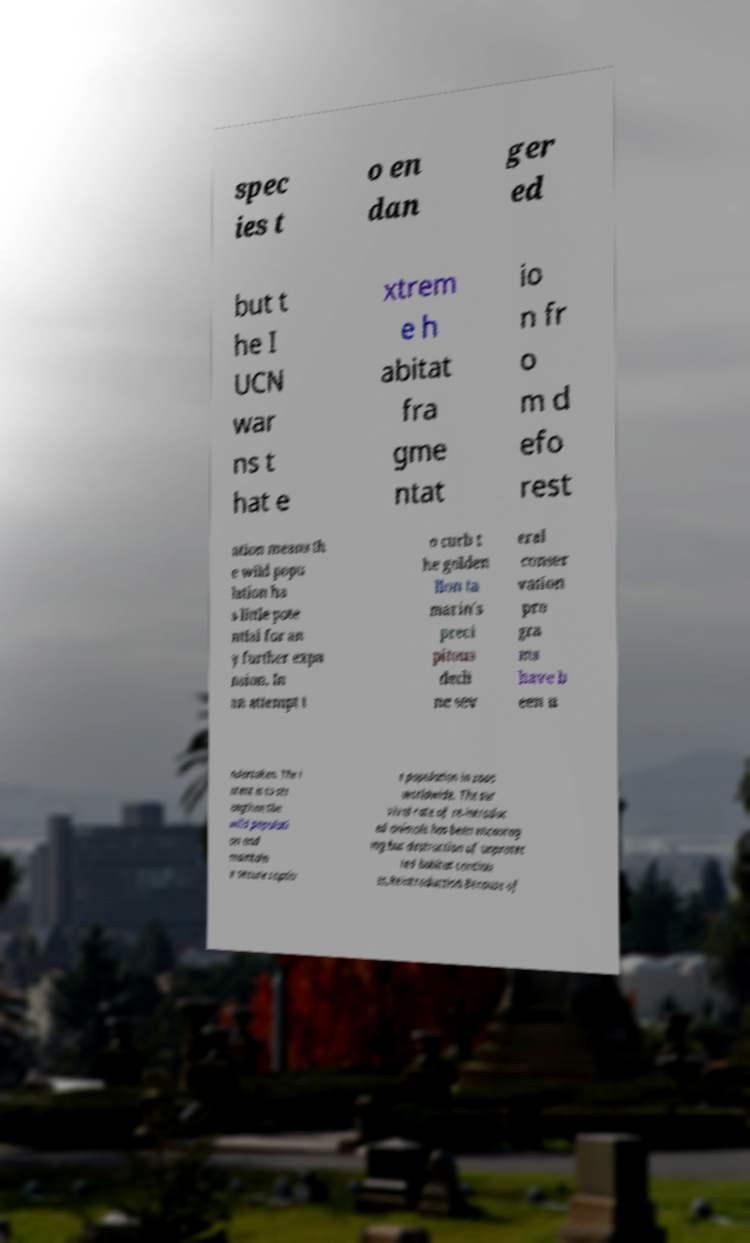Please read and relay the text visible in this image. What does it say? spec ies t o en dan ger ed but t he I UCN war ns t hat e xtrem e h abitat fra gme ntat io n fr o m d efo rest ation means th e wild popu lation ha s little pote ntial for an y further expa nsion. In an attempt t o curb t he golden lion ta marin's preci pitous decli ne sev eral conser vation pro gra ms have b een u ndertaken. The i ntent is to str engthen the wild populati on and maintain a secure captiv e population in zoos worldwide. The sur vival rate of re-introduc ed animals has been encourag ing but destruction of unprotec ted habitat continu es.Reintroduction.Because of 